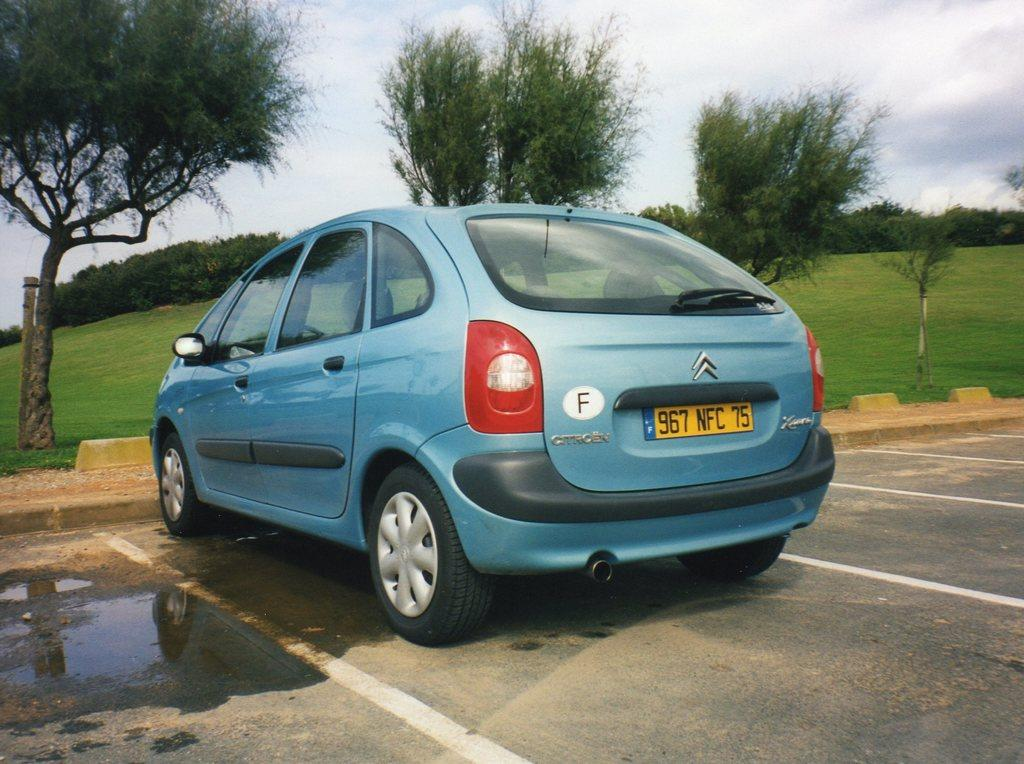What is the main subject in the foreground of the image? There is a car in the foreground of the image. Where is the car located? The car is on a road. What can be seen in the background of the image? There are trees and grass visible in the background of the image. What type of salt is being used to season the car in the image? There is no salt present in the image, and the car is not being seasoned. 